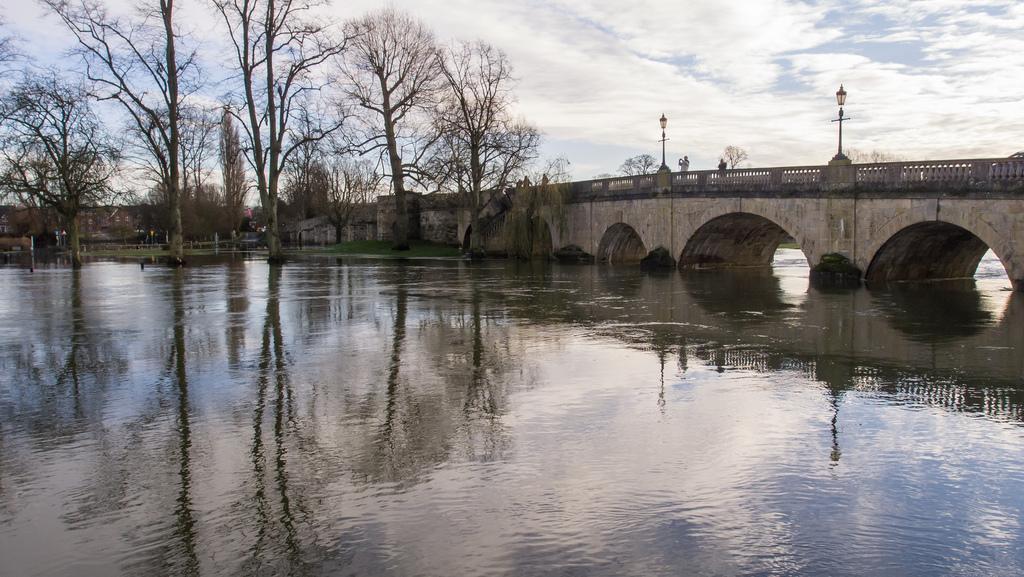Please provide a concise description of this image. This is water, in the right side it is a bridge. These are the big trees. 